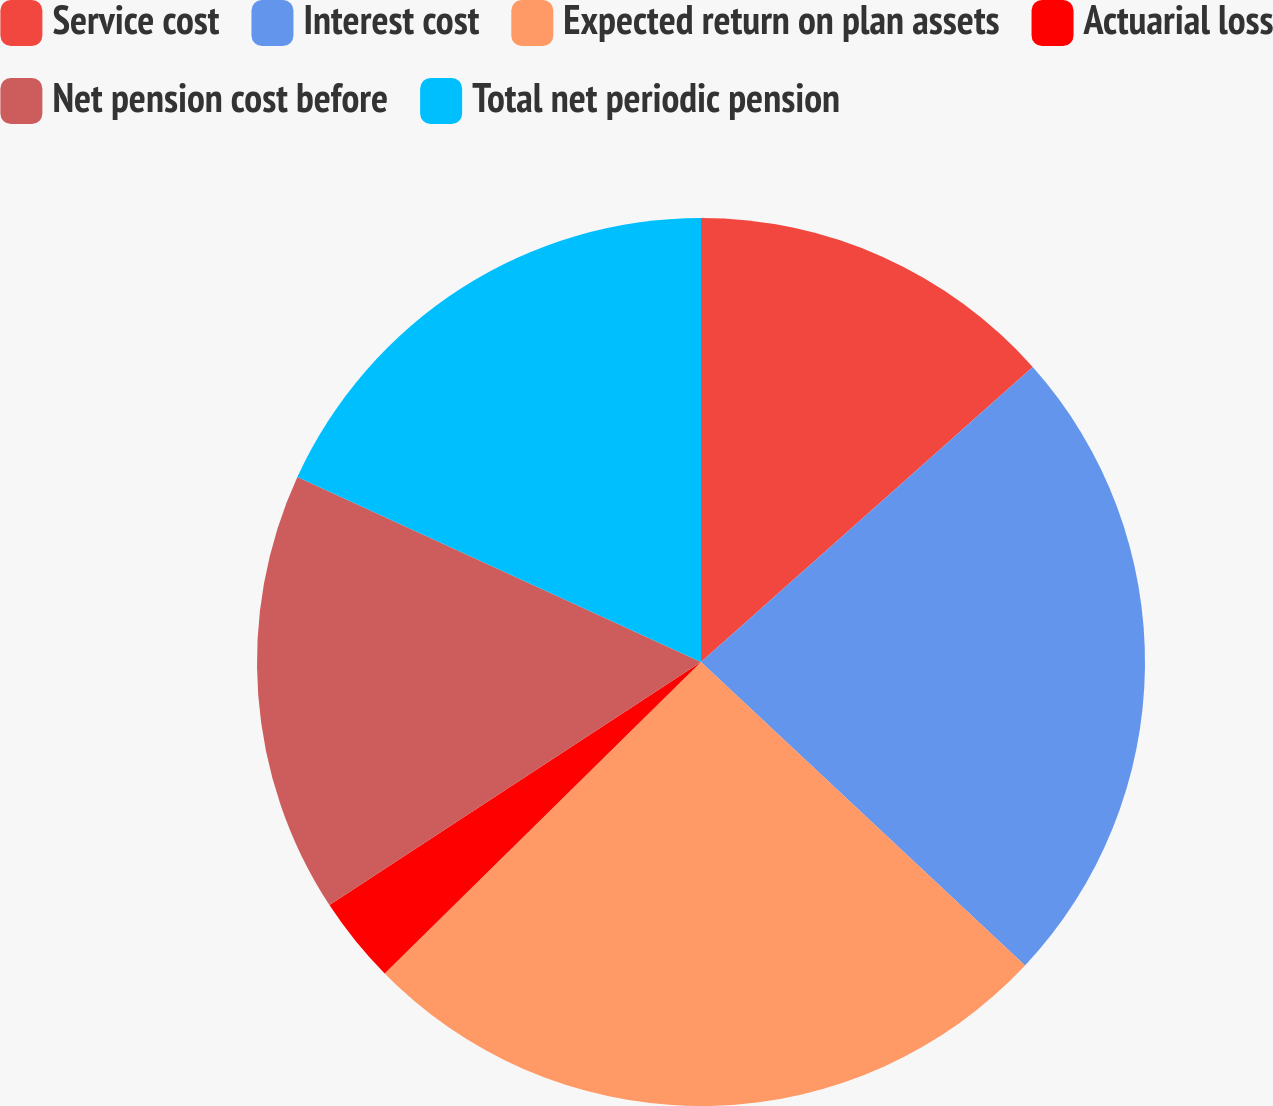Convert chart. <chart><loc_0><loc_0><loc_500><loc_500><pie_chart><fcel>Service cost<fcel>Interest cost<fcel>Expected return on plan assets<fcel>Actuarial loss<fcel>Net pension cost before<fcel>Total net periodic pension<nl><fcel>13.43%<fcel>23.55%<fcel>25.64%<fcel>3.16%<fcel>16.06%<fcel>18.16%<nl></chart> 